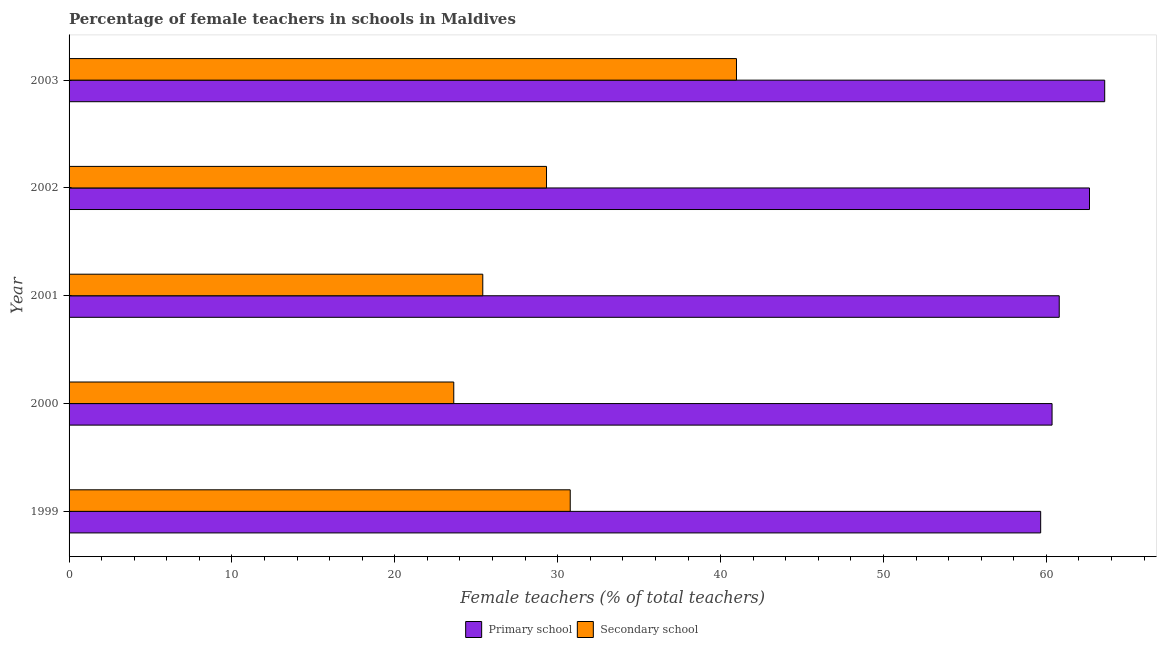Are the number of bars per tick equal to the number of legend labels?
Your answer should be compact. Yes. How many bars are there on the 5th tick from the bottom?
Keep it short and to the point. 2. What is the percentage of female teachers in primary schools in 1999?
Your answer should be very brief. 59.65. Across all years, what is the maximum percentage of female teachers in primary schools?
Your response must be concise. 63.58. Across all years, what is the minimum percentage of female teachers in primary schools?
Give a very brief answer. 59.65. What is the total percentage of female teachers in primary schools in the graph?
Provide a succinct answer. 307.03. What is the difference between the percentage of female teachers in secondary schools in 2001 and that in 2003?
Offer a very short reply. -15.58. What is the difference between the percentage of female teachers in primary schools in 2001 and the percentage of female teachers in secondary schools in 2002?
Offer a very short reply. 31.48. What is the average percentage of female teachers in primary schools per year?
Your response must be concise. 61.41. In the year 2001, what is the difference between the percentage of female teachers in secondary schools and percentage of female teachers in primary schools?
Provide a succinct answer. -35.39. What is the ratio of the percentage of female teachers in secondary schools in 1999 to that in 2003?
Your response must be concise. 0.75. Is the percentage of female teachers in secondary schools in 2000 less than that in 2002?
Your answer should be compact. Yes. What is the difference between the highest and the second highest percentage of female teachers in secondary schools?
Make the answer very short. 10.21. What is the difference between the highest and the lowest percentage of female teachers in secondary schools?
Make the answer very short. 17.36. In how many years, is the percentage of female teachers in primary schools greater than the average percentage of female teachers in primary schools taken over all years?
Your answer should be very brief. 2. Is the sum of the percentage of female teachers in primary schools in 2002 and 2003 greater than the maximum percentage of female teachers in secondary schools across all years?
Offer a very short reply. Yes. What does the 1st bar from the top in 2001 represents?
Provide a succinct answer. Secondary school. What does the 1st bar from the bottom in 2002 represents?
Keep it short and to the point. Primary school. Does the graph contain any zero values?
Ensure brevity in your answer.  No. How are the legend labels stacked?
Make the answer very short. Horizontal. What is the title of the graph?
Make the answer very short. Percentage of female teachers in schools in Maldives. What is the label or title of the X-axis?
Your answer should be compact. Female teachers (% of total teachers). What is the Female teachers (% of total teachers) of Primary school in 1999?
Your response must be concise. 59.65. What is the Female teachers (% of total teachers) of Secondary school in 1999?
Provide a succinct answer. 30.77. What is the Female teachers (% of total teachers) of Primary school in 2000?
Your response must be concise. 60.35. What is the Female teachers (% of total teachers) of Secondary school in 2000?
Offer a very short reply. 23.62. What is the Female teachers (% of total teachers) of Primary school in 2001?
Make the answer very short. 60.79. What is the Female teachers (% of total teachers) of Secondary school in 2001?
Offer a very short reply. 25.4. What is the Female teachers (% of total teachers) in Primary school in 2002?
Your answer should be very brief. 62.65. What is the Female teachers (% of total teachers) of Secondary school in 2002?
Offer a very short reply. 29.31. What is the Female teachers (% of total teachers) in Primary school in 2003?
Your response must be concise. 63.58. What is the Female teachers (% of total teachers) of Secondary school in 2003?
Your answer should be very brief. 40.98. Across all years, what is the maximum Female teachers (% of total teachers) of Primary school?
Make the answer very short. 63.58. Across all years, what is the maximum Female teachers (% of total teachers) in Secondary school?
Provide a succinct answer. 40.98. Across all years, what is the minimum Female teachers (% of total teachers) of Primary school?
Provide a short and direct response. 59.65. Across all years, what is the minimum Female teachers (% of total teachers) of Secondary school?
Ensure brevity in your answer.  23.62. What is the total Female teachers (% of total teachers) of Primary school in the graph?
Offer a terse response. 307.03. What is the total Female teachers (% of total teachers) of Secondary school in the graph?
Provide a short and direct response. 150.08. What is the difference between the Female teachers (% of total teachers) in Primary school in 1999 and that in 2000?
Make the answer very short. -0.7. What is the difference between the Female teachers (% of total teachers) of Secondary school in 1999 and that in 2000?
Provide a short and direct response. 7.15. What is the difference between the Female teachers (% of total teachers) of Primary school in 1999 and that in 2001?
Your answer should be very brief. -1.14. What is the difference between the Female teachers (% of total teachers) of Secondary school in 1999 and that in 2001?
Give a very brief answer. 5.37. What is the difference between the Female teachers (% of total teachers) in Primary school in 1999 and that in 2002?
Your answer should be very brief. -3. What is the difference between the Female teachers (% of total teachers) in Secondary school in 1999 and that in 2002?
Offer a terse response. 1.46. What is the difference between the Female teachers (% of total teachers) in Primary school in 1999 and that in 2003?
Keep it short and to the point. -3.93. What is the difference between the Female teachers (% of total teachers) of Secondary school in 1999 and that in 2003?
Your answer should be compact. -10.21. What is the difference between the Female teachers (% of total teachers) of Primary school in 2000 and that in 2001?
Your answer should be compact. -0.44. What is the difference between the Female teachers (% of total teachers) of Secondary school in 2000 and that in 2001?
Ensure brevity in your answer.  -1.78. What is the difference between the Female teachers (% of total teachers) of Primary school in 2000 and that in 2002?
Ensure brevity in your answer.  -2.3. What is the difference between the Female teachers (% of total teachers) in Secondary school in 2000 and that in 2002?
Make the answer very short. -5.69. What is the difference between the Female teachers (% of total teachers) in Primary school in 2000 and that in 2003?
Provide a short and direct response. -3.23. What is the difference between the Female teachers (% of total teachers) in Secondary school in 2000 and that in 2003?
Your answer should be very brief. -17.36. What is the difference between the Female teachers (% of total teachers) in Primary school in 2001 and that in 2002?
Keep it short and to the point. -1.86. What is the difference between the Female teachers (% of total teachers) in Secondary school in 2001 and that in 2002?
Provide a short and direct response. -3.91. What is the difference between the Female teachers (% of total teachers) in Primary school in 2001 and that in 2003?
Provide a succinct answer. -2.79. What is the difference between the Female teachers (% of total teachers) in Secondary school in 2001 and that in 2003?
Your response must be concise. -15.58. What is the difference between the Female teachers (% of total teachers) of Primary school in 2002 and that in 2003?
Provide a short and direct response. -0.93. What is the difference between the Female teachers (% of total teachers) of Secondary school in 2002 and that in 2003?
Your response must be concise. -11.66. What is the difference between the Female teachers (% of total teachers) in Primary school in 1999 and the Female teachers (% of total teachers) in Secondary school in 2000?
Your answer should be compact. 36.03. What is the difference between the Female teachers (% of total teachers) of Primary school in 1999 and the Female teachers (% of total teachers) of Secondary school in 2001?
Provide a succinct answer. 34.25. What is the difference between the Female teachers (% of total teachers) in Primary school in 1999 and the Female teachers (% of total teachers) in Secondary school in 2002?
Give a very brief answer. 30.34. What is the difference between the Female teachers (% of total teachers) of Primary school in 1999 and the Female teachers (% of total teachers) of Secondary school in 2003?
Offer a terse response. 18.68. What is the difference between the Female teachers (% of total teachers) of Primary school in 2000 and the Female teachers (% of total teachers) of Secondary school in 2001?
Your answer should be compact. 34.95. What is the difference between the Female teachers (% of total teachers) in Primary school in 2000 and the Female teachers (% of total teachers) in Secondary school in 2002?
Your response must be concise. 31.04. What is the difference between the Female teachers (% of total teachers) of Primary school in 2000 and the Female teachers (% of total teachers) of Secondary school in 2003?
Keep it short and to the point. 19.37. What is the difference between the Female teachers (% of total teachers) in Primary school in 2001 and the Female teachers (% of total teachers) in Secondary school in 2002?
Offer a terse response. 31.48. What is the difference between the Female teachers (% of total teachers) in Primary school in 2001 and the Female teachers (% of total teachers) in Secondary school in 2003?
Your answer should be compact. 19.82. What is the difference between the Female teachers (% of total teachers) of Primary school in 2002 and the Female teachers (% of total teachers) of Secondary school in 2003?
Your answer should be compact. 21.67. What is the average Female teachers (% of total teachers) in Primary school per year?
Offer a terse response. 61.41. What is the average Female teachers (% of total teachers) of Secondary school per year?
Give a very brief answer. 30.02. In the year 1999, what is the difference between the Female teachers (% of total teachers) of Primary school and Female teachers (% of total teachers) of Secondary school?
Give a very brief answer. 28.88. In the year 2000, what is the difference between the Female teachers (% of total teachers) of Primary school and Female teachers (% of total teachers) of Secondary school?
Keep it short and to the point. 36.73. In the year 2001, what is the difference between the Female teachers (% of total teachers) of Primary school and Female teachers (% of total teachers) of Secondary school?
Offer a very short reply. 35.39. In the year 2002, what is the difference between the Female teachers (% of total teachers) of Primary school and Female teachers (% of total teachers) of Secondary school?
Your response must be concise. 33.34. In the year 2003, what is the difference between the Female teachers (% of total teachers) of Primary school and Female teachers (% of total teachers) of Secondary school?
Your answer should be very brief. 22.61. What is the ratio of the Female teachers (% of total teachers) in Primary school in 1999 to that in 2000?
Ensure brevity in your answer.  0.99. What is the ratio of the Female teachers (% of total teachers) in Secondary school in 1999 to that in 2000?
Your answer should be compact. 1.3. What is the ratio of the Female teachers (% of total teachers) in Primary school in 1999 to that in 2001?
Give a very brief answer. 0.98. What is the ratio of the Female teachers (% of total teachers) in Secondary school in 1999 to that in 2001?
Ensure brevity in your answer.  1.21. What is the ratio of the Female teachers (% of total teachers) of Primary school in 1999 to that in 2002?
Give a very brief answer. 0.95. What is the ratio of the Female teachers (% of total teachers) in Secondary school in 1999 to that in 2002?
Provide a succinct answer. 1.05. What is the ratio of the Female teachers (% of total teachers) in Primary school in 1999 to that in 2003?
Keep it short and to the point. 0.94. What is the ratio of the Female teachers (% of total teachers) in Secondary school in 1999 to that in 2003?
Ensure brevity in your answer.  0.75. What is the ratio of the Female teachers (% of total teachers) in Secondary school in 2000 to that in 2001?
Your response must be concise. 0.93. What is the ratio of the Female teachers (% of total teachers) of Primary school in 2000 to that in 2002?
Your answer should be compact. 0.96. What is the ratio of the Female teachers (% of total teachers) in Secondary school in 2000 to that in 2002?
Your answer should be compact. 0.81. What is the ratio of the Female teachers (% of total teachers) of Primary school in 2000 to that in 2003?
Give a very brief answer. 0.95. What is the ratio of the Female teachers (% of total teachers) of Secondary school in 2000 to that in 2003?
Offer a terse response. 0.58. What is the ratio of the Female teachers (% of total teachers) of Primary school in 2001 to that in 2002?
Make the answer very short. 0.97. What is the ratio of the Female teachers (% of total teachers) of Secondary school in 2001 to that in 2002?
Provide a succinct answer. 0.87. What is the ratio of the Female teachers (% of total teachers) in Primary school in 2001 to that in 2003?
Provide a succinct answer. 0.96. What is the ratio of the Female teachers (% of total teachers) of Secondary school in 2001 to that in 2003?
Your response must be concise. 0.62. What is the ratio of the Female teachers (% of total teachers) in Primary school in 2002 to that in 2003?
Your answer should be compact. 0.99. What is the ratio of the Female teachers (% of total teachers) in Secondary school in 2002 to that in 2003?
Your answer should be compact. 0.72. What is the difference between the highest and the second highest Female teachers (% of total teachers) in Primary school?
Give a very brief answer. 0.93. What is the difference between the highest and the second highest Female teachers (% of total teachers) in Secondary school?
Give a very brief answer. 10.21. What is the difference between the highest and the lowest Female teachers (% of total teachers) in Primary school?
Your answer should be compact. 3.93. What is the difference between the highest and the lowest Female teachers (% of total teachers) in Secondary school?
Provide a succinct answer. 17.36. 